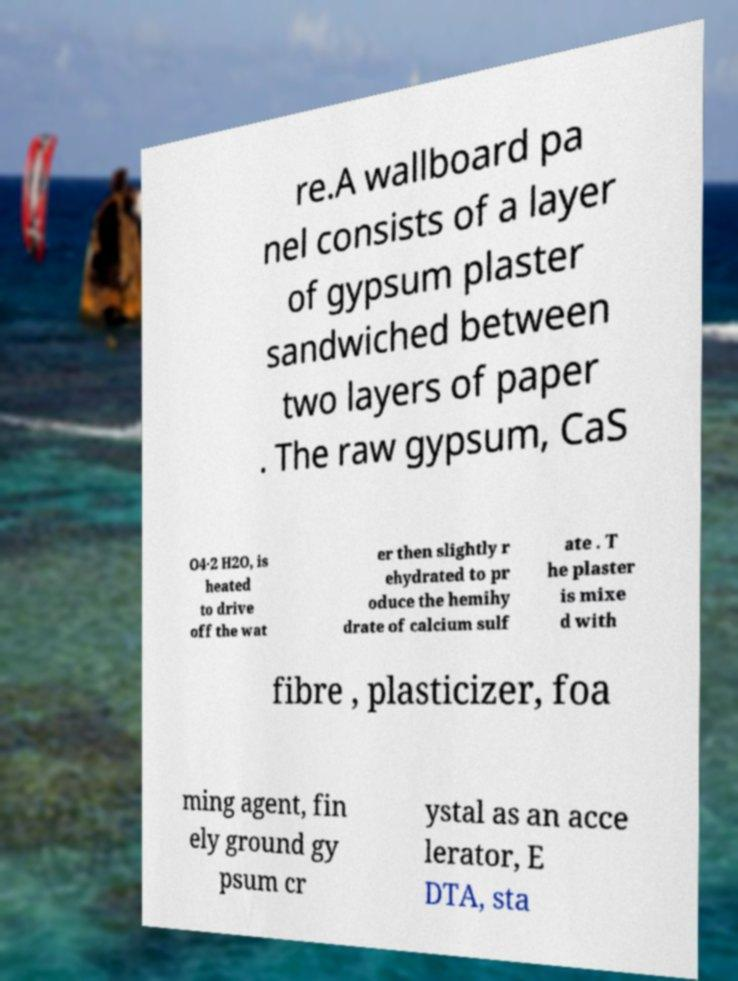Please read and relay the text visible in this image. What does it say? re.A wallboard pa nel consists of a layer of gypsum plaster sandwiched between two layers of paper . The raw gypsum, CaS O4·2 H2O, is heated to drive off the wat er then slightly r ehydrated to pr oduce the hemihy drate of calcium sulf ate . T he plaster is mixe d with fibre , plasticizer, foa ming agent, fin ely ground gy psum cr ystal as an acce lerator, E DTA, sta 